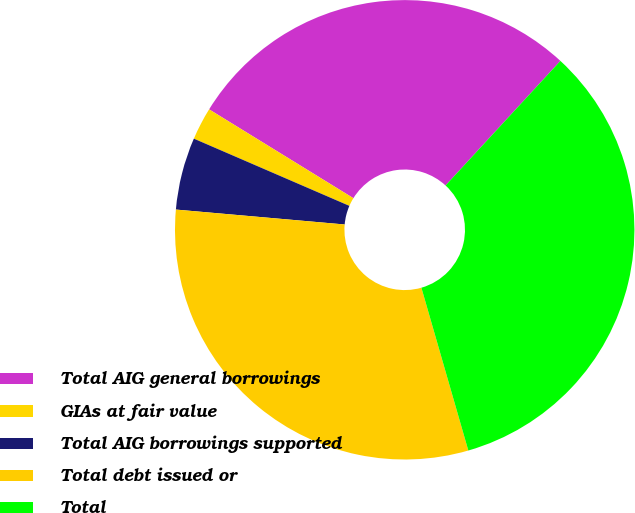Convert chart. <chart><loc_0><loc_0><loc_500><loc_500><pie_chart><fcel>Total AIG general borrowings<fcel>GIAs at fair value<fcel>Total AIG borrowings supported<fcel>Total debt issued or<fcel>Total<nl><fcel>28.07%<fcel>2.29%<fcel>5.09%<fcel>30.87%<fcel>33.68%<nl></chart> 